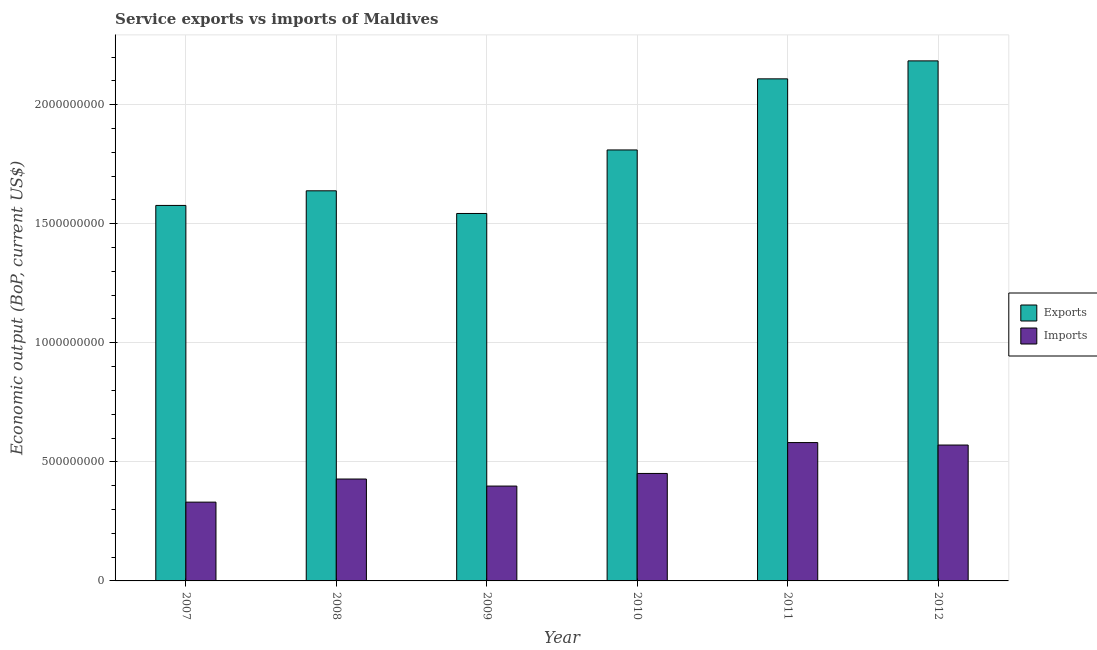How many different coloured bars are there?
Your answer should be compact. 2. How many bars are there on the 4th tick from the left?
Your answer should be compact. 2. How many bars are there on the 5th tick from the right?
Your answer should be very brief. 2. In how many cases, is the number of bars for a given year not equal to the number of legend labels?
Offer a very short reply. 0. What is the amount of service exports in 2010?
Make the answer very short. 1.81e+09. Across all years, what is the maximum amount of service exports?
Provide a succinct answer. 2.18e+09. Across all years, what is the minimum amount of service exports?
Your answer should be very brief. 1.54e+09. In which year was the amount of service exports maximum?
Offer a very short reply. 2012. What is the total amount of service exports in the graph?
Give a very brief answer. 1.09e+1. What is the difference between the amount of service exports in 2007 and that in 2010?
Your response must be concise. -2.33e+08. What is the difference between the amount of service imports in 2012 and the amount of service exports in 2011?
Your answer should be compact. -1.04e+07. What is the average amount of service exports per year?
Ensure brevity in your answer.  1.81e+09. What is the ratio of the amount of service exports in 2010 to that in 2012?
Provide a short and direct response. 0.83. What is the difference between the highest and the second highest amount of service exports?
Keep it short and to the point. 7.55e+07. What is the difference between the highest and the lowest amount of service exports?
Provide a succinct answer. 6.41e+08. Is the sum of the amount of service exports in 2010 and 2012 greater than the maximum amount of service imports across all years?
Offer a very short reply. Yes. What does the 1st bar from the left in 2010 represents?
Provide a short and direct response. Exports. What does the 2nd bar from the right in 2007 represents?
Provide a short and direct response. Exports. How many bars are there?
Provide a short and direct response. 12. How many years are there in the graph?
Your response must be concise. 6. What is the difference between two consecutive major ticks on the Y-axis?
Provide a succinct answer. 5.00e+08. Are the values on the major ticks of Y-axis written in scientific E-notation?
Provide a short and direct response. No. Does the graph contain any zero values?
Your response must be concise. No. Does the graph contain grids?
Keep it short and to the point. Yes. How many legend labels are there?
Keep it short and to the point. 2. How are the legend labels stacked?
Provide a short and direct response. Vertical. What is the title of the graph?
Your answer should be very brief. Service exports vs imports of Maldives. Does "Commercial bank branches" appear as one of the legend labels in the graph?
Provide a short and direct response. No. What is the label or title of the X-axis?
Offer a terse response. Year. What is the label or title of the Y-axis?
Your answer should be very brief. Economic output (BoP, current US$). What is the Economic output (BoP, current US$) of Exports in 2007?
Provide a short and direct response. 1.58e+09. What is the Economic output (BoP, current US$) of Imports in 2007?
Keep it short and to the point. 3.31e+08. What is the Economic output (BoP, current US$) in Exports in 2008?
Your answer should be very brief. 1.64e+09. What is the Economic output (BoP, current US$) in Imports in 2008?
Offer a terse response. 4.28e+08. What is the Economic output (BoP, current US$) of Exports in 2009?
Ensure brevity in your answer.  1.54e+09. What is the Economic output (BoP, current US$) in Imports in 2009?
Your answer should be compact. 3.98e+08. What is the Economic output (BoP, current US$) in Exports in 2010?
Make the answer very short. 1.81e+09. What is the Economic output (BoP, current US$) in Imports in 2010?
Offer a terse response. 4.51e+08. What is the Economic output (BoP, current US$) in Exports in 2011?
Your answer should be very brief. 2.11e+09. What is the Economic output (BoP, current US$) in Imports in 2011?
Provide a succinct answer. 5.81e+08. What is the Economic output (BoP, current US$) in Exports in 2012?
Give a very brief answer. 2.18e+09. What is the Economic output (BoP, current US$) in Imports in 2012?
Your answer should be compact. 5.71e+08. Across all years, what is the maximum Economic output (BoP, current US$) in Exports?
Provide a succinct answer. 2.18e+09. Across all years, what is the maximum Economic output (BoP, current US$) of Imports?
Make the answer very short. 5.81e+08. Across all years, what is the minimum Economic output (BoP, current US$) in Exports?
Your answer should be compact. 1.54e+09. Across all years, what is the minimum Economic output (BoP, current US$) of Imports?
Keep it short and to the point. 3.31e+08. What is the total Economic output (BoP, current US$) in Exports in the graph?
Your answer should be very brief. 1.09e+1. What is the total Economic output (BoP, current US$) in Imports in the graph?
Ensure brevity in your answer.  2.76e+09. What is the difference between the Economic output (BoP, current US$) of Exports in 2007 and that in 2008?
Offer a terse response. -6.14e+07. What is the difference between the Economic output (BoP, current US$) in Imports in 2007 and that in 2008?
Provide a succinct answer. -9.70e+07. What is the difference between the Economic output (BoP, current US$) of Exports in 2007 and that in 2009?
Offer a terse response. 3.38e+07. What is the difference between the Economic output (BoP, current US$) of Imports in 2007 and that in 2009?
Keep it short and to the point. -6.74e+07. What is the difference between the Economic output (BoP, current US$) in Exports in 2007 and that in 2010?
Ensure brevity in your answer.  -2.33e+08. What is the difference between the Economic output (BoP, current US$) in Imports in 2007 and that in 2010?
Keep it short and to the point. -1.20e+08. What is the difference between the Economic output (BoP, current US$) of Exports in 2007 and that in 2011?
Your answer should be very brief. -5.32e+08. What is the difference between the Economic output (BoP, current US$) in Imports in 2007 and that in 2011?
Make the answer very short. -2.50e+08. What is the difference between the Economic output (BoP, current US$) in Exports in 2007 and that in 2012?
Your answer should be very brief. -6.07e+08. What is the difference between the Economic output (BoP, current US$) in Imports in 2007 and that in 2012?
Provide a succinct answer. -2.40e+08. What is the difference between the Economic output (BoP, current US$) of Exports in 2008 and that in 2009?
Keep it short and to the point. 9.52e+07. What is the difference between the Economic output (BoP, current US$) in Imports in 2008 and that in 2009?
Ensure brevity in your answer.  2.96e+07. What is the difference between the Economic output (BoP, current US$) of Exports in 2008 and that in 2010?
Provide a succinct answer. -1.72e+08. What is the difference between the Economic output (BoP, current US$) in Imports in 2008 and that in 2010?
Give a very brief answer. -2.34e+07. What is the difference between the Economic output (BoP, current US$) in Exports in 2008 and that in 2011?
Provide a succinct answer. -4.70e+08. What is the difference between the Economic output (BoP, current US$) in Imports in 2008 and that in 2011?
Keep it short and to the point. -1.53e+08. What is the difference between the Economic output (BoP, current US$) in Exports in 2008 and that in 2012?
Keep it short and to the point. -5.46e+08. What is the difference between the Economic output (BoP, current US$) in Imports in 2008 and that in 2012?
Offer a very short reply. -1.43e+08. What is the difference between the Economic output (BoP, current US$) in Exports in 2009 and that in 2010?
Provide a short and direct response. -2.67e+08. What is the difference between the Economic output (BoP, current US$) in Imports in 2009 and that in 2010?
Your answer should be compact. -5.30e+07. What is the difference between the Economic output (BoP, current US$) in Exports in 2009 and that in 2011?
Make the answer very short. -5.65e+08. What is the difference between the Economic output (BoP, current US$) of Imports in 2009 and that in 2011?
Make the answer very short. -1.83e+08. What is the difference between the Economic output (BoP, current US$) of Exports in 2009 and that in 2012?
Your answer should be compact. -6.41e+08. What is the difference between the Economic output (BoP, current US$) of Imports in 2009 and that in 2012?
Your response must be concise. -1.72e+08. What is the difference between the Economic output (BoP, current US$) of Exports in 2010 and that in 2011?
Give a very brief answer. -2.99e+08. What is the difference between the Economic output (BoP, current US$) in Imports in 2010 and that in 2011?
Your response must be concise. -1.30e+08. What is the difference between the Economic output (BoP, current US$) of Exports in 2010 and that in 2012?
Make the answer very short. -3.74e+08. What is the difference between the Economic output (BoP, current US$) of Imports in 2010 and that in 2012?
Keep it short and to the point. -1.19e+08. What is the difference between the Economic output (BoP, current US$) of Exports in 2011 and that in 2012?
Your response must be concise. -7.55e+07. What is the difference between the Economic output (BoP, current US$) of Imports in 2011 and that in 2012?
Ensure brevity in your answer.  1.04e+07. What is the difference between the Economic output (BoP, current US$) of Exports in 2007 and the Economic output (BoP, current US$) of Imports in 2008?
Make the answer very short. 1.15e+09. What is the difference between the Economic output (BoP, current US$) of Exports in 2007 and the Economic output (BoP, current US$) of Imports in 2009?
Provide a succinct answer. 1.18e+09. What is the difference between the Economic output (BoP, current US$) in Exports in 2007 and the Economic output (BoP, current US$) in Imports in 2010?
Your answer should be compact. 1.13e+09. What is the difference between the Economic output (BoP, current US$) in Exports in 2007 and the Economic output (BoP, current US$) in Imports in 2011?
Keep it short and to the point. 9.96e+08. What is the difference between the Economic output (BoP, current US$) of Exports in 2007 and the Economic output (BoP, current US$) of Imports in 2012?
Make the answer very short. 1.01e+09. What is the difference between the Economic output (BoP, current US$) in Exports in 2008 and the Economic output (BoP, current US$) in Imports in 2009?
Keep it short and to the point. 1.24e+09. What is the difference between the Economic output (BoP, current US$) in Exports in 2008 and the Economic output (BoP, current US$) in Imports in 2010?
Your answer should be compact. 1.19e+09. What is the difference between the Economic output (BoP, current US$) in Exports in 2008 and the Economic output (BoP, current US$) in Imports in 2011?
Your answer should be compact. 1.06e+09. What is the difference between the Economic output (BoP, current US$) in Exports in 2008 and the Economic output (BoP, current US$) in Imports in 2012?
Offer a very short reply. 1.07e+09. What is the difference between the Economic output (BoP, current US$) in Exports in 2009 and the Economic output (BoP, current US$) in Imports in 2010?
Your answer should be compact. 1.09e+09. What is the difference between the Economic output (BoP, current US$) in Exports in 2009 and the Economic output (BoP, current US$) in Imports in 2011?
Keep it short and to the point. 9.62e+08. What is the difference between the Economic output (BoP, current US$) of Exports in 2009 and the Economic output (BoP, current US$) of Imports in 2012?
Offer a terse response. 9.73e+08. What is the difference between the Economic output (BoP, current US$) in Exports in 2010 and the Economic output (BoP, current US$) in Imports in 2011?
Offer a very short reply. 1.23e+09. What is the difference between the Economic output (BoP, current US$) in Exports in 2010 and the Economic output (BoP, current US$) in Imports in 2012?
Provide a short and direct response. 1.24e+09. What is the difference between the Economic output (BoP, current US$) in Exports in 2011 and the Economic output (BoP, current US$) in Imports in 2012?
Make the answer very short. 1.54e+09. What is the average Economic output (BoP, current US$) of Exports per year?
Offer a terse response. 1.81e+09. What is the average Economic output (BoP, current US$) in Imports per year?
Keep it short and to the point. 4.60e+08. In the year 2007, what is the difference between the Economic output (BoP, current US$) in Exports and Economic output (BoP, current US$) in Imports?
Your answer should be compact. 1.25e+09. In the year 2008, what is the difference between the Economic output (BoP, current US$) of Exports and Economic output (BoP, current US$) of Imports?
Make the answer very short. 1.21e+09. In the year 2009, what is the difference between the Economic output (BoP, current US$) of Exports and Economic output (BoP, current US$) of Imports?
Ensure brevity in your answer.  1.14e+09. In the year 2010, what is the difference between the Economic output (BoP, current US$) in Exports and Economic output (BoP, current US$) in Imports?
Your answer should be compact. 1.36e+09. In the year 2011, what is the difference between the Economic output (BoP, current US$) of Exports and Economic output (BoP, current US$) of Imports?
Offer a very short reply. 1.53e+09. In the year 2012, what is the difference between the Economic output (BoP, current US$) in Exports and Economic output (BoP, current US$) in Imports?
Your response must be concise. 1.61e+09. What is the ratio of the Economic output (BoP, current US$) of Exports in 2007 to that in 2008?
Your answer should be very brief. 0.96. What is the ratio of the Economic output (BoP, current US$) of Imports in 2007 to that in 2008?
Offer a terse response. 0.77. What is the ratio of the Economic output (BoP, current US$) of Exports in 2007 to that in 2009?
Give a very brief answer. 1.02. What is the ratio of the Economic output (BoP, current US$) in Imports in 2007 to that in 2009?
Your response must be concise. 0.83. What is the ratio of the Economic output (BoP, current US$) of Exports in 2007 to that in 2010?
Ensure brevity in your answer.  0.87. What is the ratio of the Economic output (BoP, current US$) in Imports in 2007 to that in 2010?
Give a very brief answer. 0.73. What is the ratio of the Economic output (BoP, current US$) of Exports in 2007 to that in 2011?
Your answer should be compact. 0.75. What is the ratio of the Economic output (BoP, current US$) of Imports in 2007 to that in 2011?
Your answer should be compact. 0.57. What is the ratio of the Economic output (BoP, current US$) of Exports in 2007 to that in 2012?
Offer a very short reply. 0.72. What is the ratio of the Economic output (BoP, current US$) of Imports in 2007 to that in 2012?
Offer a very short reply. 0.58. What is the ratio of the Economic output (BoP, current US$) in Exports in 2008 to that in 2009?
Provide a succinct answer. 1.06. What is the ratio of the Economic output (BoP, current US$) of Imports in 2008 to that in 2009?
Give a very brief answer. 1.07. What is the ratio of the Economic output (BoP, current US$) in Exports in 2008 to that in 2010?
Your response must be concise. 0.91. What is the ratio of the Economic output (BoP, current US$) in Imports in 2008 to that in 2010?
Provide a succinct answer. 0.95. What is the ratio of the Economic output (BoP, current US$) of Exports in 2008 to that in 2011?
Provide a short and direct response. 0.78. What is the ratio of the Economic output (BoP, current US$) of Imports in 2008 to that in 2011?
Your response must be concise. 0.74. What is the ratio of the Economic output (BoP, current US$) of Exports in 2008 to that in 2012?
Give a very brief answer. 0.75. What is the ratio of the Economic output (BoP, current US$) in Imports in 2008 to that in 2012?
Offer a terse response. 0.75. What is the ratio of the Economic output (BoP, current US$) of Exports in 2009 to that in 2010?
Give a very brief answer. 0.85. What is the ratio of the Economic output (BoP, current US$) of Imports in 2009 to that in 2010?
Keep it short and to the point. 0.88. What is the ratio of the Economic output (BoP, current US$) of Exports in 2009 to that in 2011?
Your answer should be very brief. 0.73. What is the ratio of the Economic output (BoP, current US$) in Imports in 2009 to that in 2011?
Provide a succinct answer. 0.69. What is the ratio of the Economic output (BoP, current US$) in Exports in 2009 to that in 2012?
Offer a terse response. 0.71. What is the ratio of the Economic output (BoP, current US$) in Imports in 2009 to that in 2012?
Provide a succinct answer. 0.7. What is the ratio of the Economic output (BoP, current US$) in Exports in 2010 to that in 2011?
Ensure brevity in your answer.  0.86. What is the ratio of the Economic output (BoP, current US$) of Imports in 2010 to that in 2011?
Your response must be concise. 0.78. What is the ratio of the Economic output (BoP, current US$) of Exports in 2010 to that in 2012?
Make the answer very short. 0.83. What is the ratio of the Economic output (BoP, current US$) in Imports in 2010 to that in 2012?
Provide a short and direct response. 0.79. What is the ratio of the Economic output (BoP, current US$) in Exports in 2011 to that in 2012?
Make the answer very short. 0.97. What is the ratio of the Economic output (BoP, current US$) of Imports in 2011 to that in 2012?
Your response must be concise. 1.02. What is the difference between the highest and the second highest Economic output (BoP, current US$) in Exports?
Provide a succinct answer. 7.55e+07. What is the difference between the highest and the second highest Economic output (BoP, current US$) in Imports?
Give a very brief answer. 1.04e+07. What is the difference between the highest and the lowest Economic output (BoP, current US$) in Exports?
Keep it short and to the point. 6.41e+08. What is the difference between the highest and the lowest Economic output (BoP, current US$) in Imports?
Offer a very short reply. 2.50e+08. 